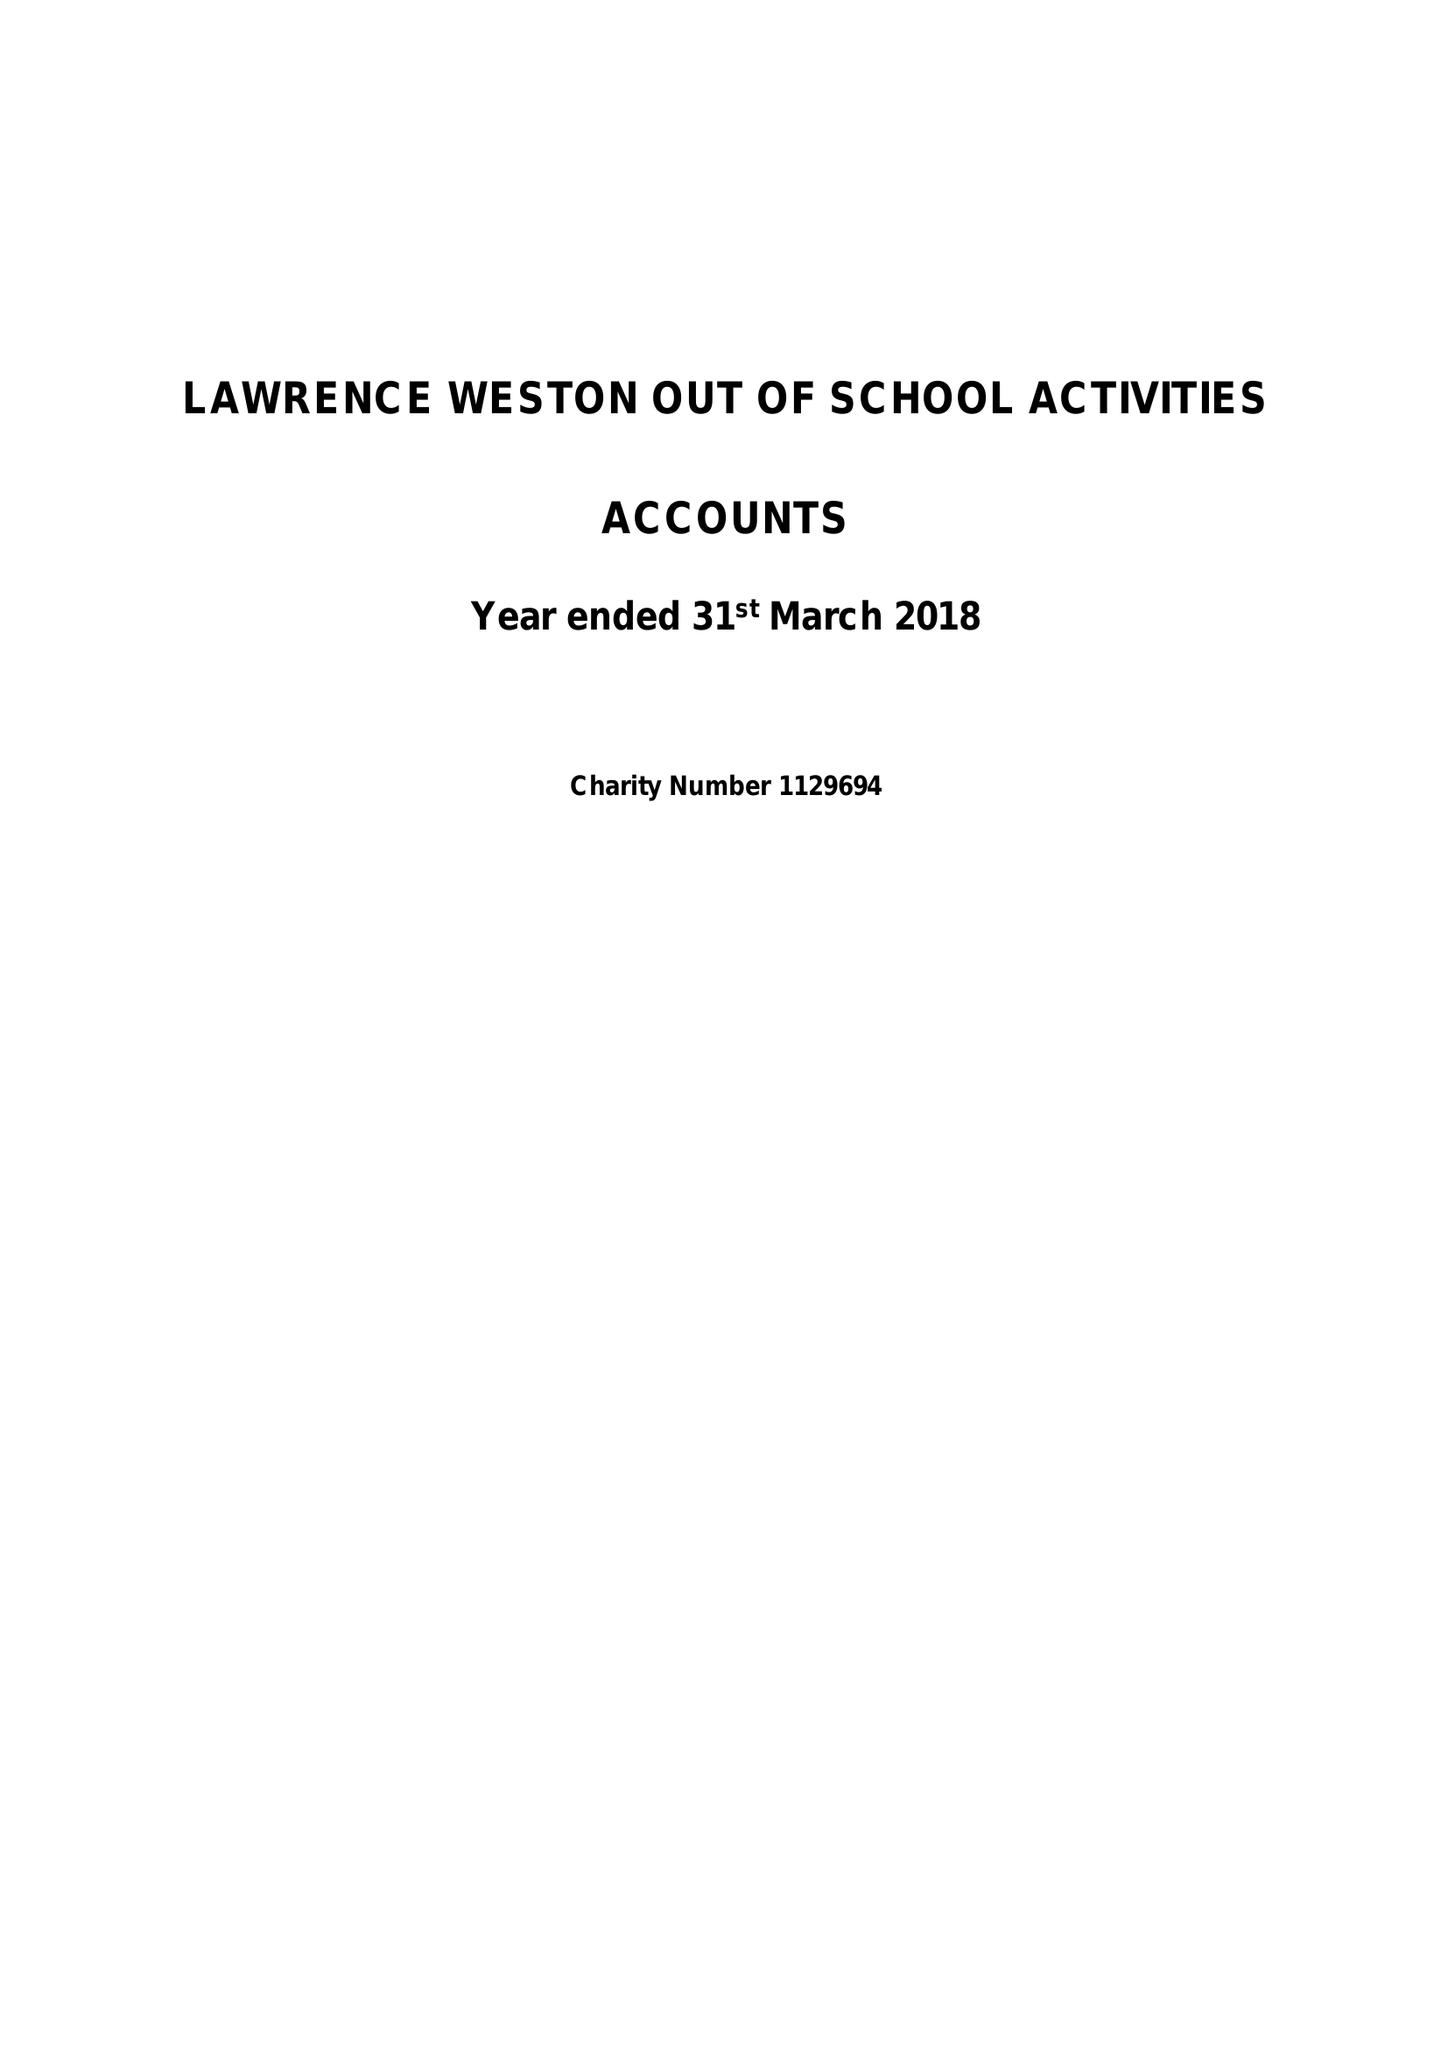What is the value for the address__street_line?
Answer the question using a single word or phrase. RIDINGLEAZE 